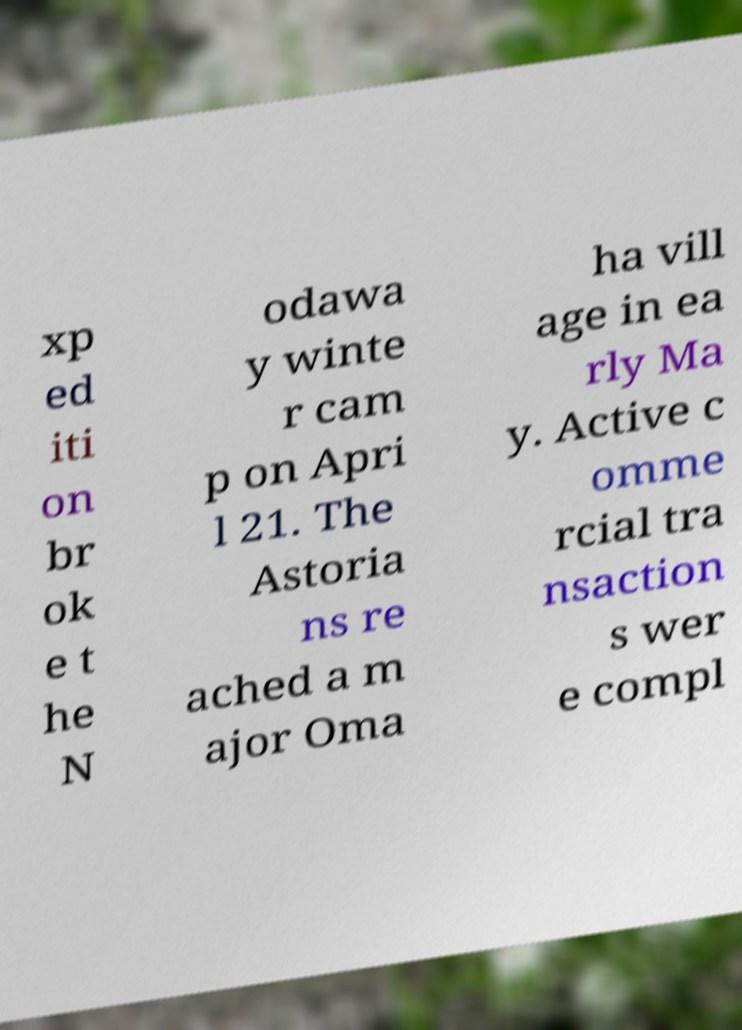What messages or text are displayed in this image? I need them in a readable, typed format. xp ed iti on br ok e t he N odawa y winte r cam p on Apri l 21. The Astoria ns re ached a m ajor Oma ha vill age in ea rly Ma y. Active c omme rcial tra nsaction s wer e compl 